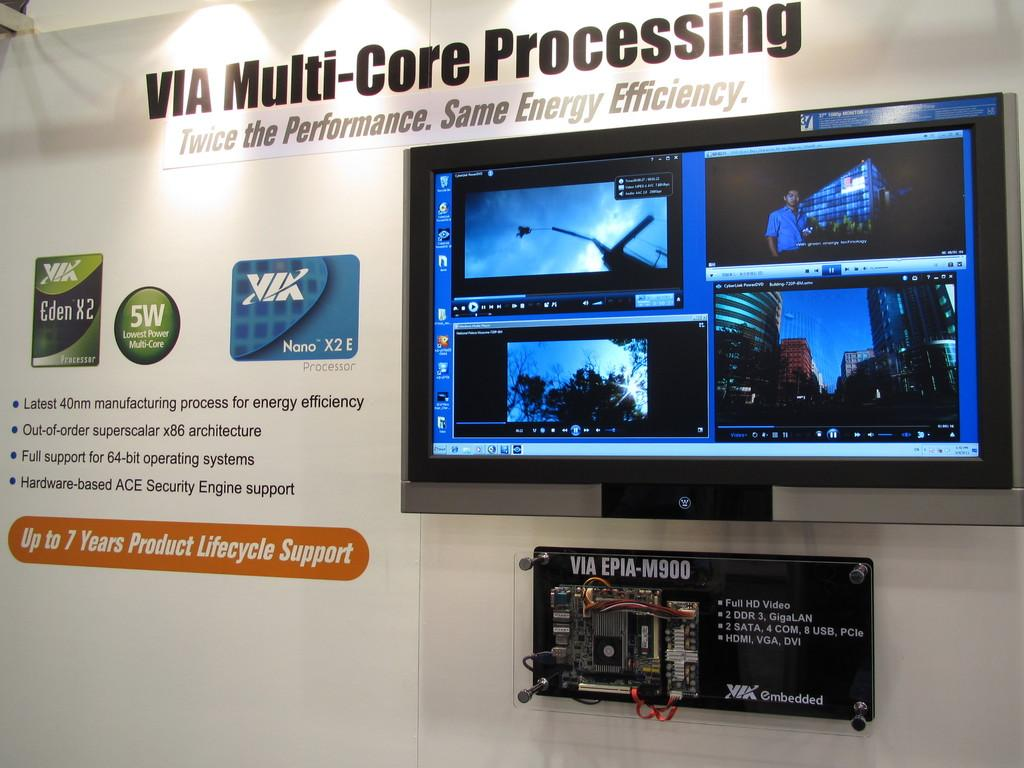<image>
Summarize the visual content of the image. A poster with a TV screen next to ads for KiK and a 5W sign. 